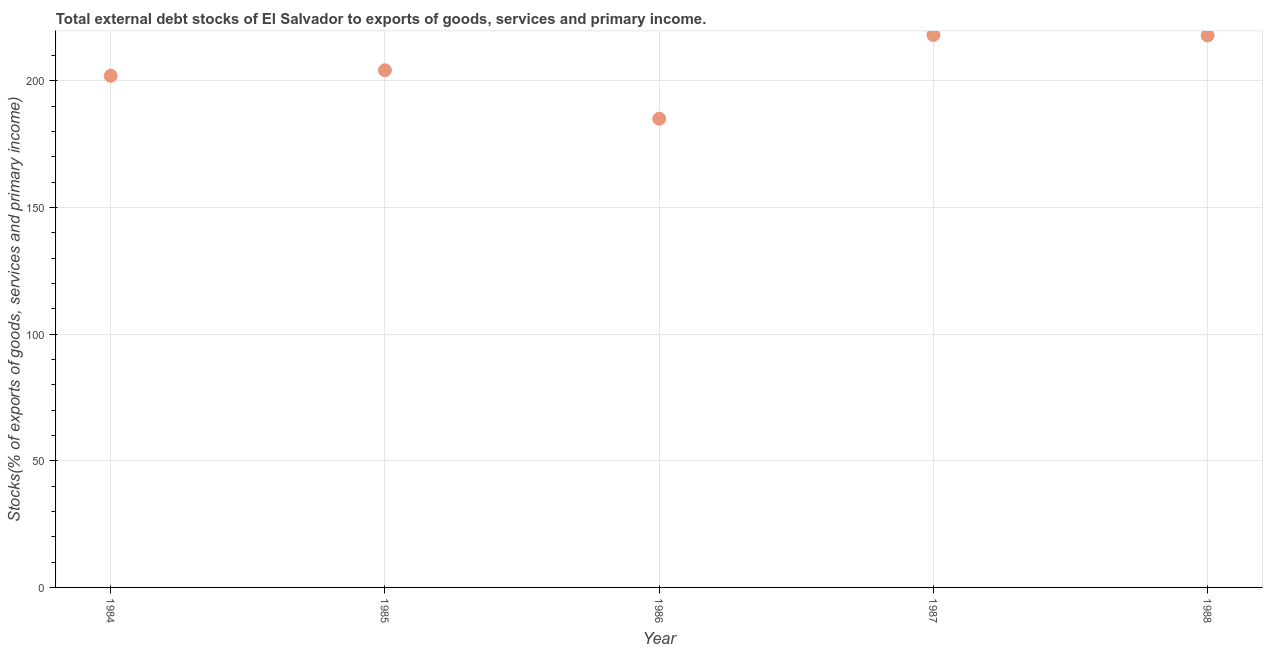What is the external debt stocks in 1987?
Offer a terse response. 218.15. Across all years, what is the maximum external debt stocks?
Your answer should be very brief. 218.15. Across all years, what is the minimum external debt stocks?
Give a very brief answer. 185.1. What is the sum of the external debt stocks?
Your answer should be compact. 1027.47. What is the difference between the external debt stocks in 1985 and 1986?
Keep it short and to the point. 19.12. What is the average external debt stocks per year?
Give a very brief answer. 205.49. What is the median external debt stocks?
Offer a very short reply. 204.22. Do a majority of the years between 1985 and 1988 (inclusive) have external debt stocks greater than 90 %?
Offer a very short reply. Yes. What is the ratio of the external debt stocks in 1984 to that in 1985?
Your answer should be very brief. 0.99. Is the difference between the external debt stocks in 1984 and 1986 greater than the difference between any two years?
Keep it short and to the point. No. What is the difference between the highest and the second highest external debt stocks?
Provide a succinct answer. 0.16. Is the sum of the external debt stocks in 1984 and 1985 greater than the maximum external debt stocks across all years?
Ensure brevity in your answer.  Yes. What is the difference between the highest and the lowest external debt stocks?
Keep it short and to the point. 33.05. What is the difference between two consecutive major ticks on the Y-axis?
Ensure brevity in your answer.  50. What is the title of the graph?
Give a very brief answer. Total external debt stocks of El Salvador to exports of goods, services and primary income. What is the label or title of the X-axis?
Provide a succinct answer. Year. What is the label or title of the Y-axis?
Ensure brevity in your answer.  Stocks(% of exports of goods, services and primary income). What is the Stocks(% of exports of goods, services and primary income) in 1984?
Make the answer very short. 202.03. What is the Stocks(% of exports of goods, services and primary income) in 1985?
Provide a succinct answer. 204.22. What is the Stocks(% of exports of goods, services and primary income) in 1986?
Give a very brief answer. 185.1. What is the Stocks(% of exports of goods, services and primary income) in 1987?
Offer a terse response. 218.15. What is the Stocks(% of exports of goods, services and primary income) in 1988?
Your answer should be compact. 217.98. What is the difference between the Stocks(% of exports of goods, services and primary income) in 1984 and 1985?
Offer a terse response. -2.18. What is the difference between the Stocks(% of exports of goods, services and primary income) in 1984 and 1986?
Your response must be concise. 16.93. What is the difference between the Stocks(% of exports of goods, services and primary income) in 1984 and 1987?
Provide a short and direct response. -16.11. What is the difference between the Stocks(% of exports of goods, services and primary income) in 1984 and 1988?
Your response must be concise. -15.95. What is the difference between the Stocks(% of exports of goods, services and primary income) in 1985 and 1986?
Keep it short and to the point. 19.12. What is the difference between the Stocks(% of exports of goods, services and primary income) in 1985 and 1987?
Give a very brief answer. -13.93. What is the difference between the Stocks(% of exports of goods, services and primary income) in 1985 and 1988?
Your response must be concise. -13.77. What is the difference between the Stocks(% of exports of goods, services and primary income) in 1986 and 1987?
Give a very brief answer. -33.05. What is the difference between the Stocks(% of exports of goods, services and primary income) in 1986 and 1988?
Make the answer very short. -32.89. What is the difference between the Stocks(% of exports of goods, services and primary income) in 1987 and 1988?
Provide a short and direct response. 0.16. What is the ratio of the Stocks(% of exports of goods, services and primary income) in 1984 to that in 1986?
Give a very brief answer. 1.09. What is the ratio of the Stocks(% of exports of goods, services and primary income) in 1984 to that in 1987?
Offer a very short reply. 0.93. What is the ratio of the Stocks(% of exports of goods, services and primary income) in 1984 to that in 1988?
Make the answer very short. 0.93. What is the ratio of the Stocks(% of exports of goods, services and primary income) in 1985 to that in 1986?
Provide a short and direct response. 1.1. What is the ratio of the Stocks(% of exports of goods, services and primary income) in 1985 to that in 1987?
Your response must be concise. 0.94. What is the ratio of the Stocks(% of exports of goods, services and primary income) in 1985 to that in 1988?
Your answer should be compact. 0.94. What is the ratio of the Stocks(% of exports of goods, services and primary income) in 1986 to that in 1987?
Offer a very short reply. 0.85. What is the ratio of the Stocks(% of exports of goods, services and primary income) in 1986 to that in 1988?
Your answer should be very brief. 0.85. 